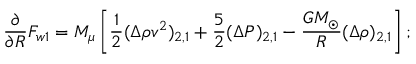Convert formula to latex. <formula><loc_0><loc_0><loc_500><loc_500>\frac { \partial } { \partial R } F _ { w 1 } = M _ { \mu } \left [ \frac { 1 } { 2 } ( \Delta \rho v ^ { 2 } ) _ { 2 , 1 } + \frac { 5 } { 2 } ( \Delta P ) _ { 2 , 1 } - \frac { G M _ { \odot } } { R } ( \Delta \rho ) _ { 2 , 1 } \right ] ;</formula> 